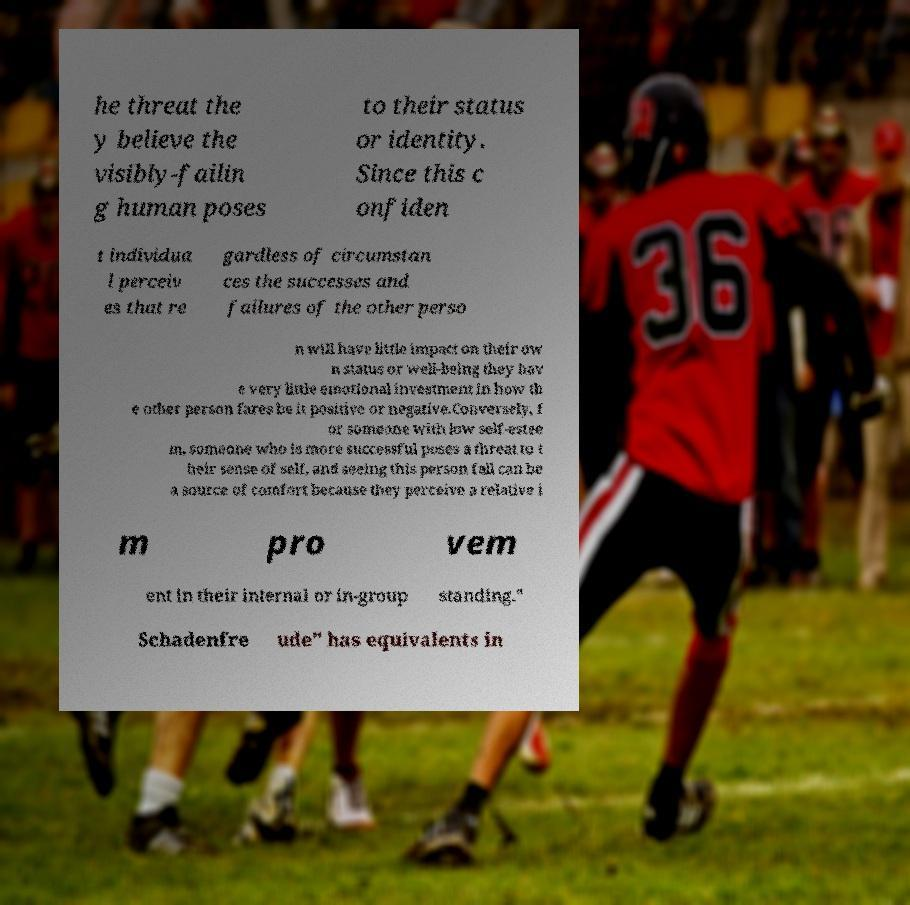Please read and relay the text visible in this image. What does it say? he threat the y believe the visibly-failin g human poses to their status or identity. Since this c onfiden t individua l perceiv es that re gardless of circumstan ces the successes and failures of the other perso n will have little impact on their ow n status or well-being they hav e very little emotional investment in how th e other person fares be it positive or negative.Conversely, f or someone with low self-estee m, someone who is more successful poses a threat to t heir sense of self, and seeing this person fall can be a source of comfort because they perceive a relative i m pro vem ent in their internal or in-group standing." Schadenfre ude" has equivalents in 